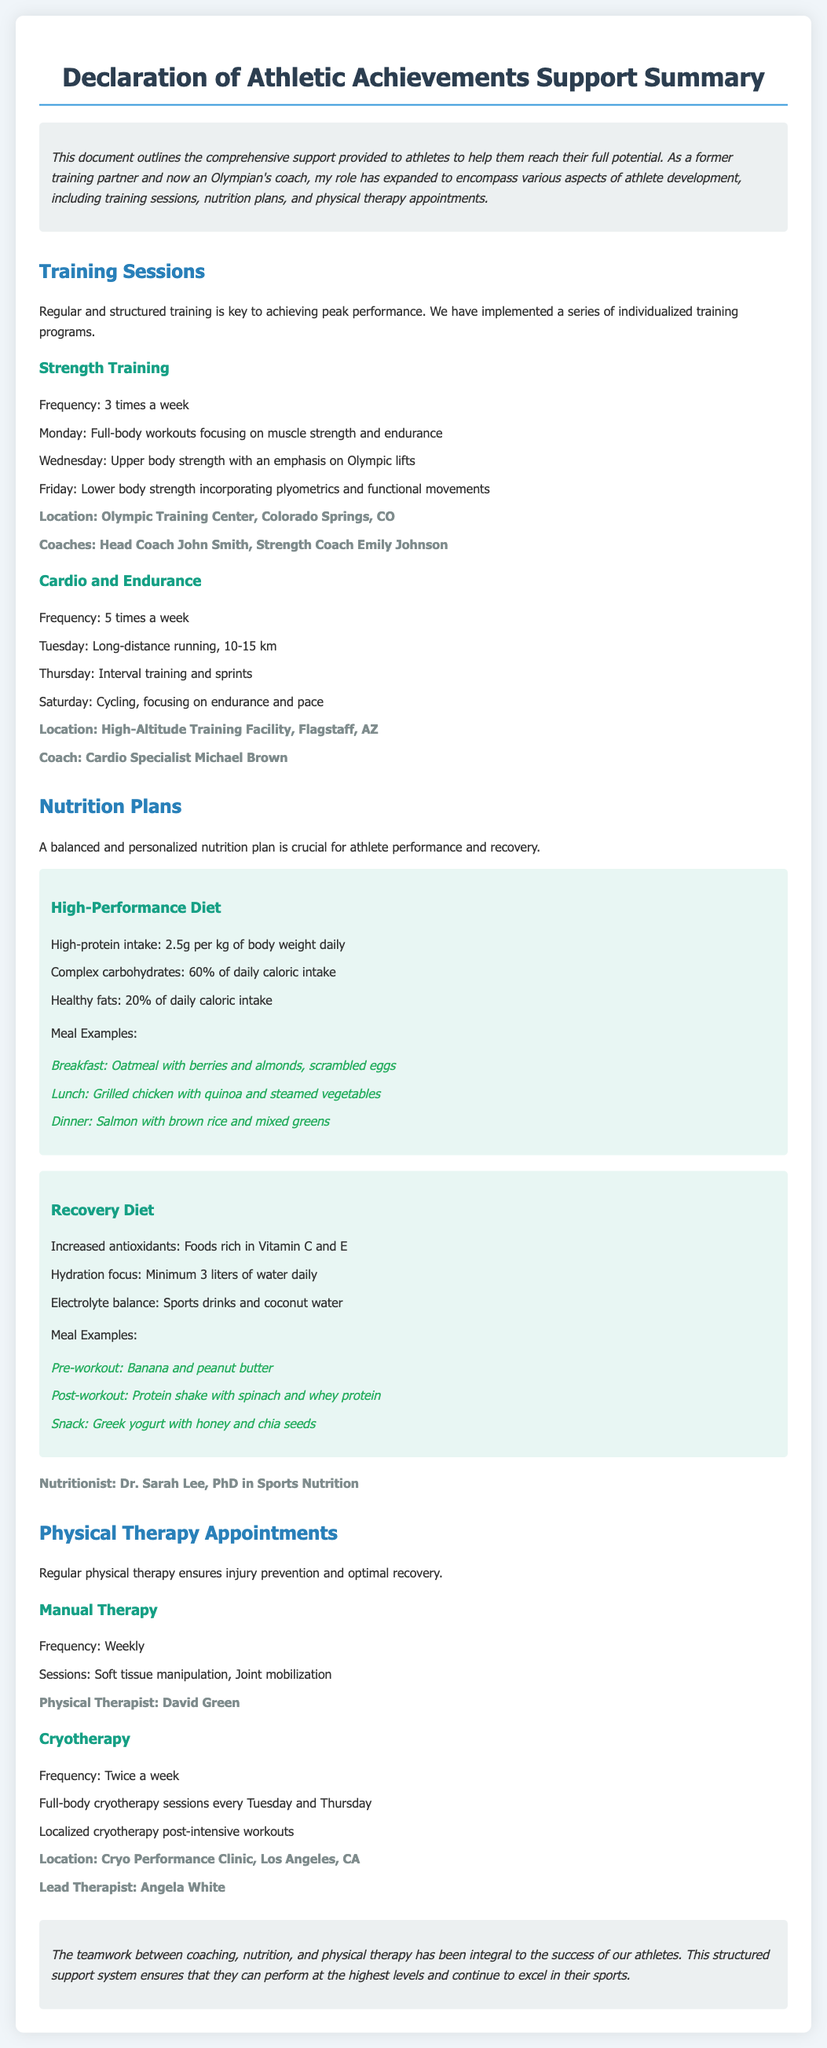What are the primary coaching roles in strength training? The document states that the primary coaching roles in strength training are Head Coach John Smith and Strength Coach Emily Johnson.
Answer: Head Coach John Smith, Strength Coach Emily Johnson How often are cardio sessions conducted per week? The document mentions that cardio sessions are conducted 5 times a week for endurance training.
Answer: 5 times What nutritionist is mentioned in the document? The document specifies that Dr. Sarah Lee is the nutritionist with a PhD in Sports Nutrition.
Answer: Dr. Sarah Lee What type of therapy is provided weekly? The document states that manual therapy sessions are conducted weekly for athletes.
Answer: Manual Therapy How many times a week is cryotherapy performed? According to the document, cryotherapy is performed twice a week.
Answer: Twice a week Which location is specified for strength training sessions? The document indicates that the location for strength training sessions is the Olympic Training Center in Colorado Springs, CO.
Answer: Olympic Training Center, Colorado Springs, CO What is included in the high-performance diet regarding protein intake? The document specifies that the high-performance diet includes a high-protein intake of 2.5 grams per kg of body weight daily.
Answer: 2.5g per kg of body weight daily What is the purpose of regular physical therapy appointments? The document outlines that regular physical therapy ensures injury prevention and optimal recovery for athletes.
Answer: Injury prevention and optimal recovery What day is long-distance running scheduled? The document states that long-distance running is scheduled for Tuesday.
Answer: Tuesday 